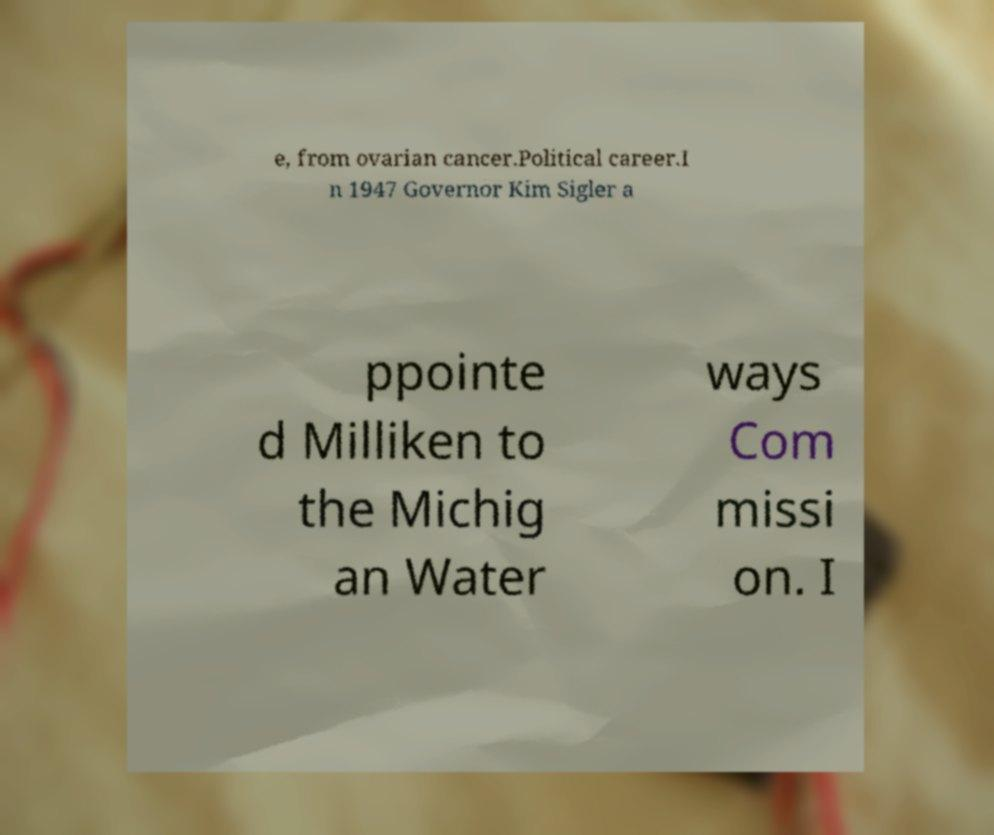Can you accurately transcribe the text from the provided image for me? e, from ovarian cancer.Political career.I n 1947 Governor Kim Sigler a ppointe d Milliken to the Michig an Water ways Com missi on. I 